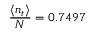<formula> <loc_0><loc_0><loc_500><loc_500>\frac { \langle n _ { t } \rangle } { N } = 0 . 7 4 9 7</formula> 